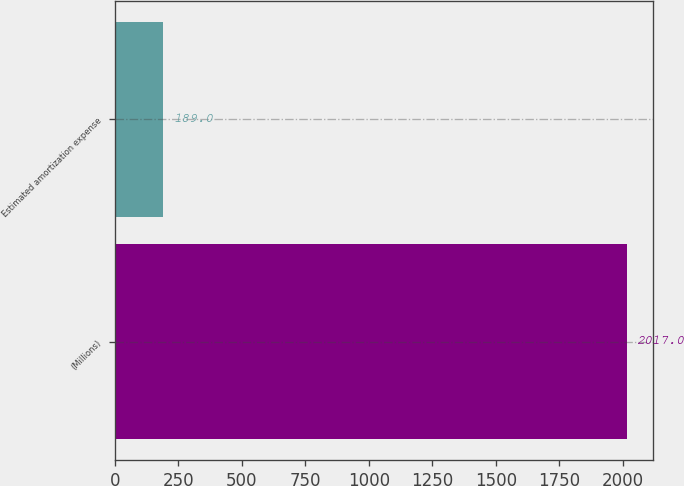Convert chart to OTSL. <chart><loc_0><loc_0><loc_500><loc_500><bar_chart><fcel>(Millions)<fcel>Estimated amortization expense<nl><fcel>2017<fcel>189<nl></chart> 